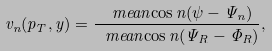Convert formula to latex. <formula><loc_0><loc_0><loc_500><loc_500>v _ { n } ( p _ { T } , y ) = \frac { \ m e a n { \cos n ( \psi - \Psi _ { n } ) } } { \ m e a n { \cos n ( \Psi _ { R } - \Phi _ { R } ) } } ,</formula> 